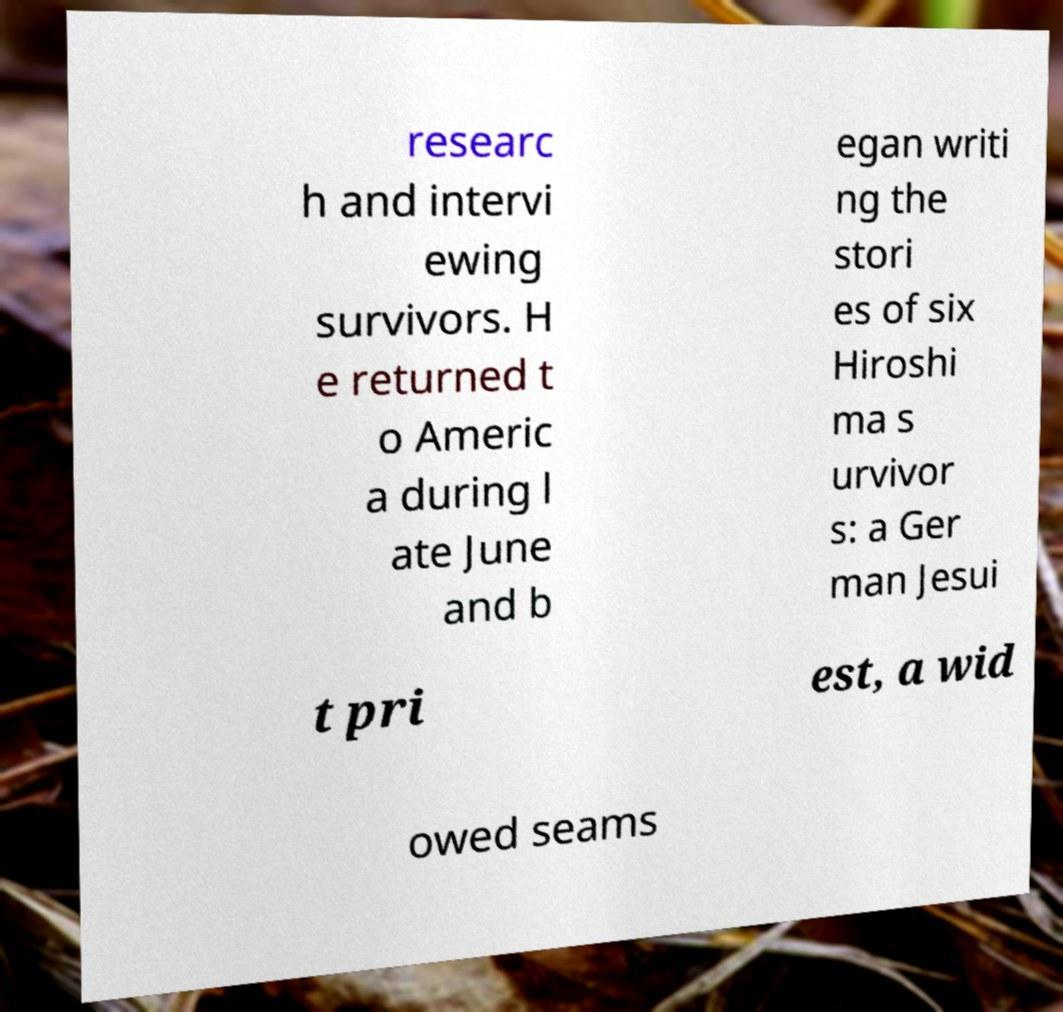Can you accurately transcribe the text from the provided image for me? researc h and intervi ewing survivors. H e returned t o Americ a during l ate June and b egan writi ng the stori es of six Hiroshi ma s urvivor s: a Ger man Jesui t pri est, a wid owed seams 